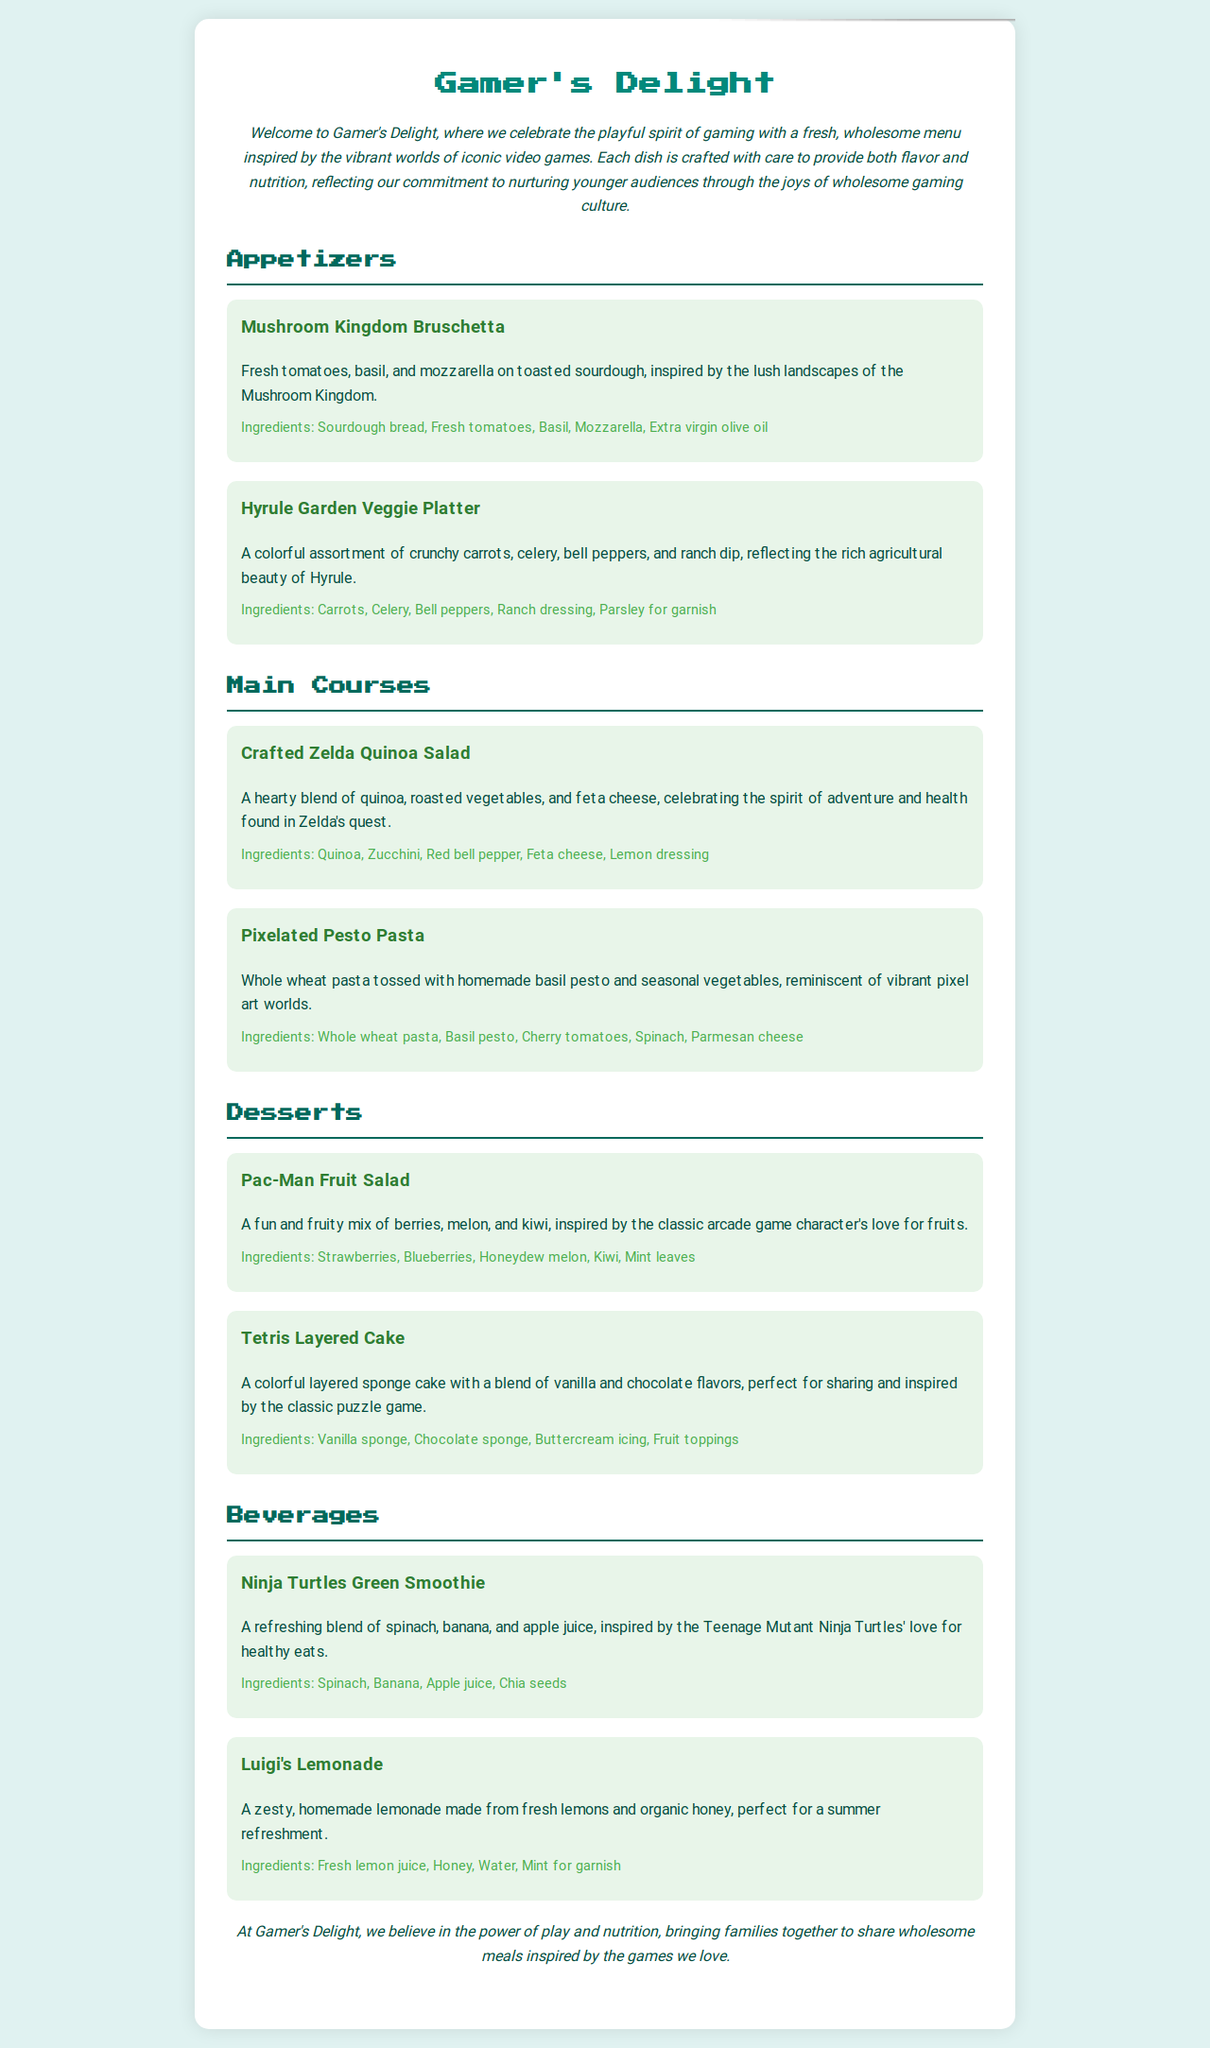What is the name of the first appetizer? The first appetizer listed in the document is named "Mushroom Kingdom Bruschetta."
Answer: Mushroom Kingdom Bruschetta How many main courses are there? The document lists two main courses under the "Main Courses" section.
Answer: 2 What ingredients are in the Pac-Man Fruit Salad? The ingredients listed for the Pac-Man Fruit Salad are strawberries, blueberries, honeydew melon, kiwi, and mint leaves.
Answer: Strawberries, Blueberries, Honeydew melon, Kiwi, Mint leaves Which beverage is inspired by Teenage Mutant Ninja Turtles? The beverage specifically inspired by the Teenage Mutant Ninja Turtles is named "Ninja Turtles Green Smoothie."
Answer: Ninja Turtles Green Smoothie What is the main ingredient in Luigi's Lemonade? The main ingredient in Luigi's Lemonade is fresh lemon juice.
Answer: Fresh lemon juice What type of cuisine does "Gamer's Delight" focus on? The menu focuses on wholesome ingredients and nutrition suitable for younger audiences, inspired by video games.
Answer: Wholesome ingredients inspired by video games What type of cake is inspired by Tetris? The cake inspired by Tetris is a "Tetris Layered Cake."
Answer: Tetris Layered Cake What is the purpose of the "Gamer's Delight" menu? The purpose of the menu is to celebrate gaming culture while promoting nutrition and wholesome meals for families.
Answer: Promote nutrition and wholesome meals How many items are listed in the Desserts section? There are two dessert items listed in the Desserts section of the menu.
Answer: 2 